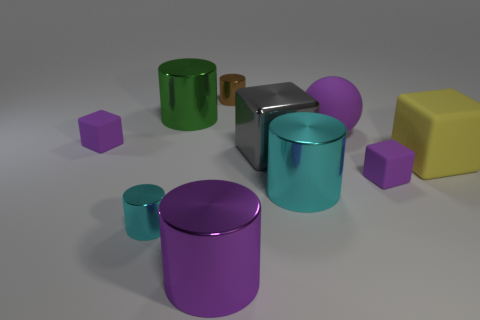Subtract all green cylinders. How many cylinders are left? 4 Subtract 1 blocks. How many blocks are left? 3 Subtract all purple cylinders. How many cylinders are left? 4 Subtract all red cylinders. Subtract all yellow balls. How many cylinders are left? 5 Subtract all balls. How many objects are left? 9 Add 2 big yellow rubber objects. How many big yellow rubber objects exist? 3 Subtract 0 yellow balls. How many objects are left? 10 Subtract all purple matte cubes. Subtract all large green metallic cylinders. How many objects are left? 7 Add 6 matte blocks. How many matte blocks are left? 9 